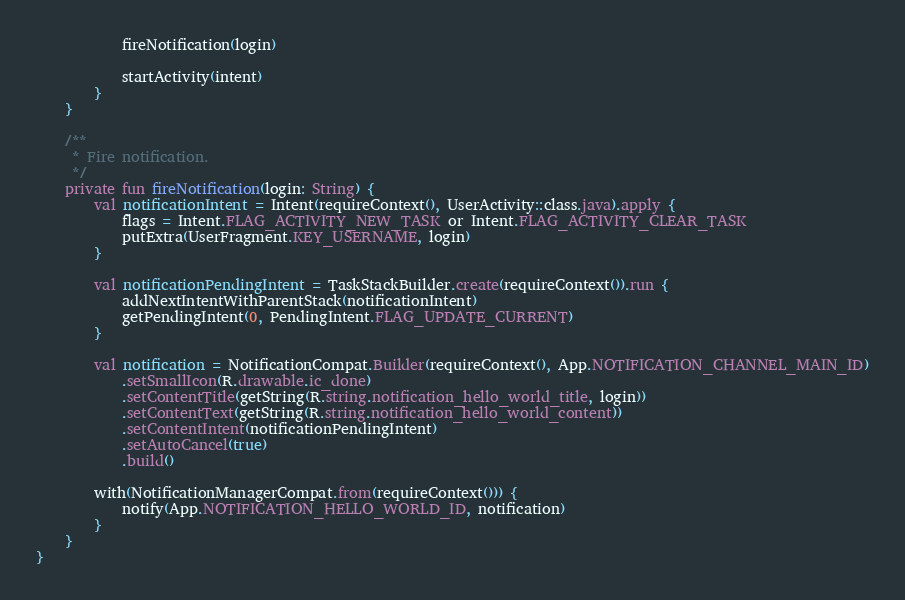Convert code to text. <code><loc_0><loc_0><loc_500><loc_500><_Kotlin_>            fireNotification(login)

            startActivity(intent)
        }
    }

    /**
     * Fire notification.
     */
    private fun fireNotification(login: String) {
        val notificationIntent = Intent(requireContext(), UserActivity::class.java).apply {
            flags = Intent.FLAG_ACTIVITY_NEW_TASK or Intent.FLAG_ACTIVITY_CLEAR_TASK
            putExtra(UserFragment.KEY_USERNAME, login)
        }

        val notificationPendingIntent = TaskStackBuilder.create(requireContext()).run {
            addNextIntentWithParentStack(notificationIntent)
            getPendingIntent(0, PendingIntent.FLAG_UPDATE_CURRENT)
        }

        val notification = NotificationCompat.Builder(requireContext(), App.NOTIFICATION_CHANNEL_MAIN_ID)
            .setSmallIcon(R.drawable.ic_done)
            .setContentTitle(getString(R.string.notification_hello_world_title, login))
            .setContentText(getString(R.string.notification_hello_world_content))
            .setContentIntent(notificationPendingIntent)
            .setAutoCancel(true)
            .build()

        with(NotificationManagerCompat.from(requireContext())) {
            notify(App.NOTIFICATION_HELLO_WORLD_ID, notification)
        }
    }
}</code> 